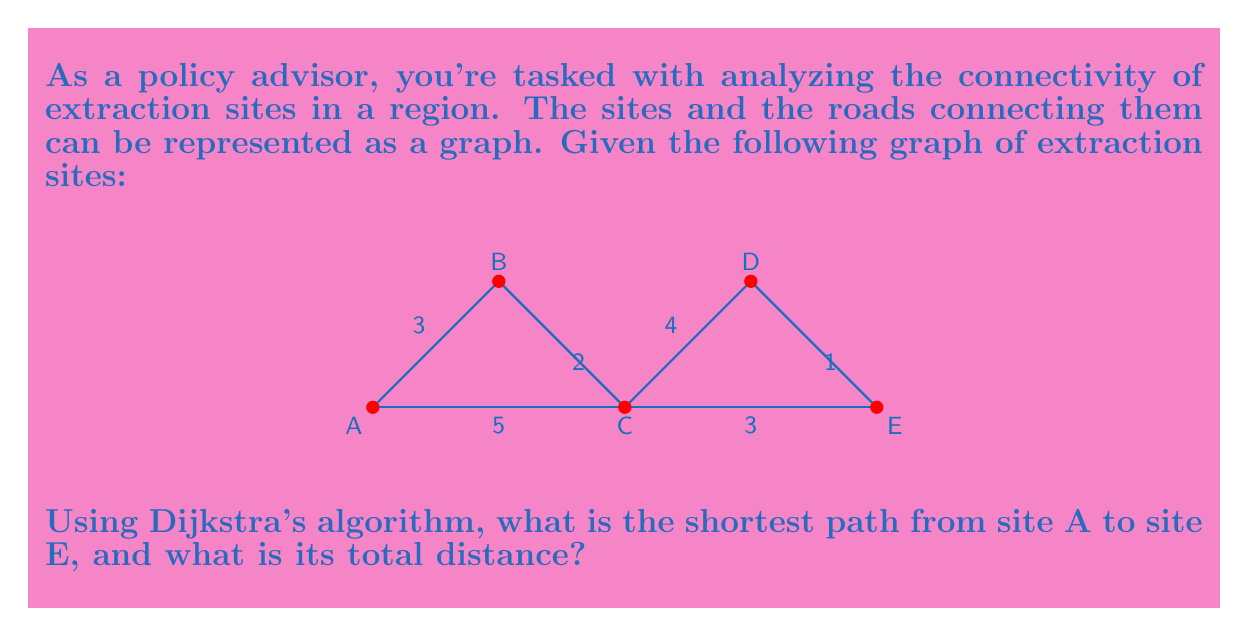Give your solution to this math problem. To solve this problem, we'll apply Dijkstra's algorithm to find the shortest path from A to E. Here's a step-by-step explanation:

1) Initialize:
   - Set distance to A as 0, and all other nodes as infinity.
   - Set all nodes as unvisited.
   - Set A as the current node.

2) For the current node, consider all unvisited neighbors and calculate their tentative distances.
   - From A: B (3), C (5)

3) Update distances if smaller than the previously recorded distance:
   - B: 3
   - C: 5

4) Mark A as visited. B has the smallest tentative distance, so make it the current node.

5) From B:
   - C: min(5, 3+2) = 5 (no change)
   - D: 3+2+4 = 9

6) Mark B as visited. C has the smallest tentative distance among unvisited nodes, so it becomes the current node.

7) From C:
   - D: min(9, 5+4) = 9 (no change)
   - E: 5+3 = 8

8) Mark C as visited. E has the smallest tentative distance among unvisited nodes, so it becomes the current node.

9) The algorithm terminates as we've reached the target node E.

The shortest path is A-C-E with a total distance of 8.
Answer: A-C-E, 8 